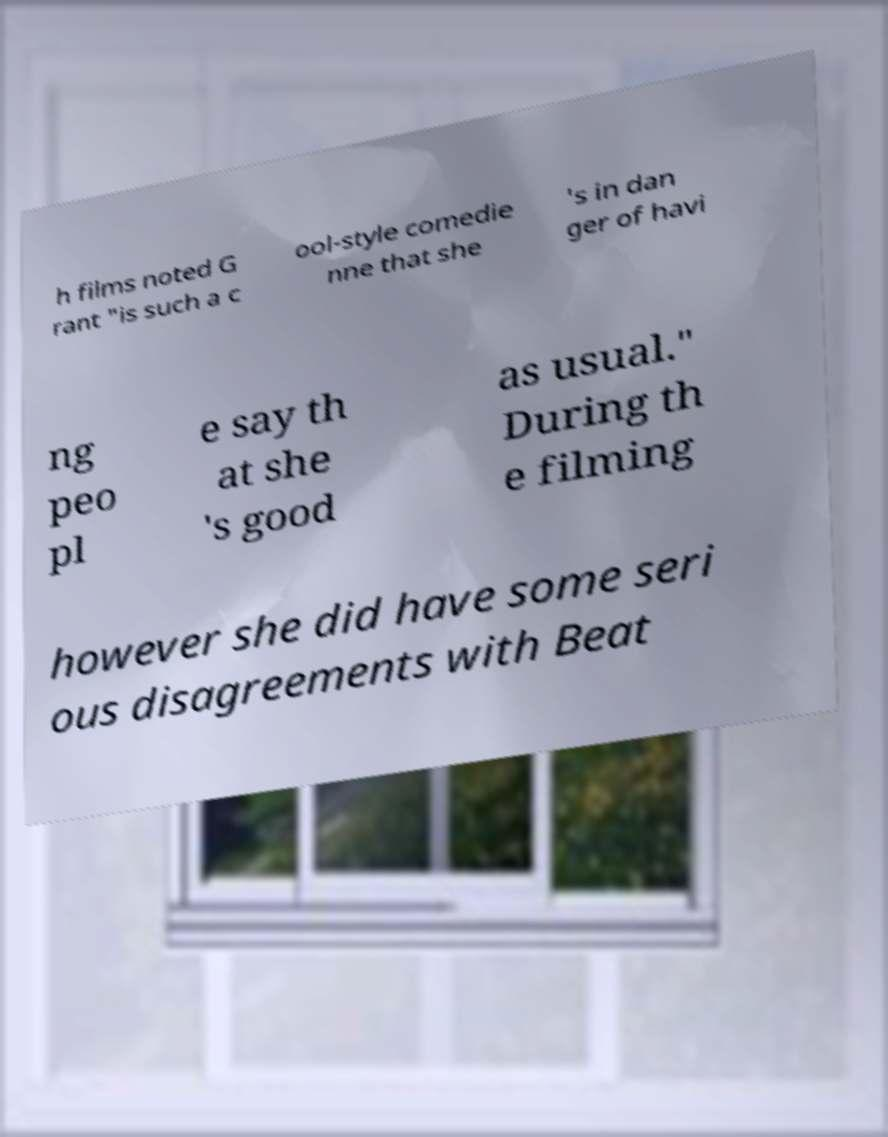Please read and relay the text visible in this image. What does it say? h films noted G rant "is such a c ool-style comedie nne that she 's in dan ger of havi ng peo pl e say th at she 's good as usual." During th e filming however she did have some seri ous disagreements with Beat 